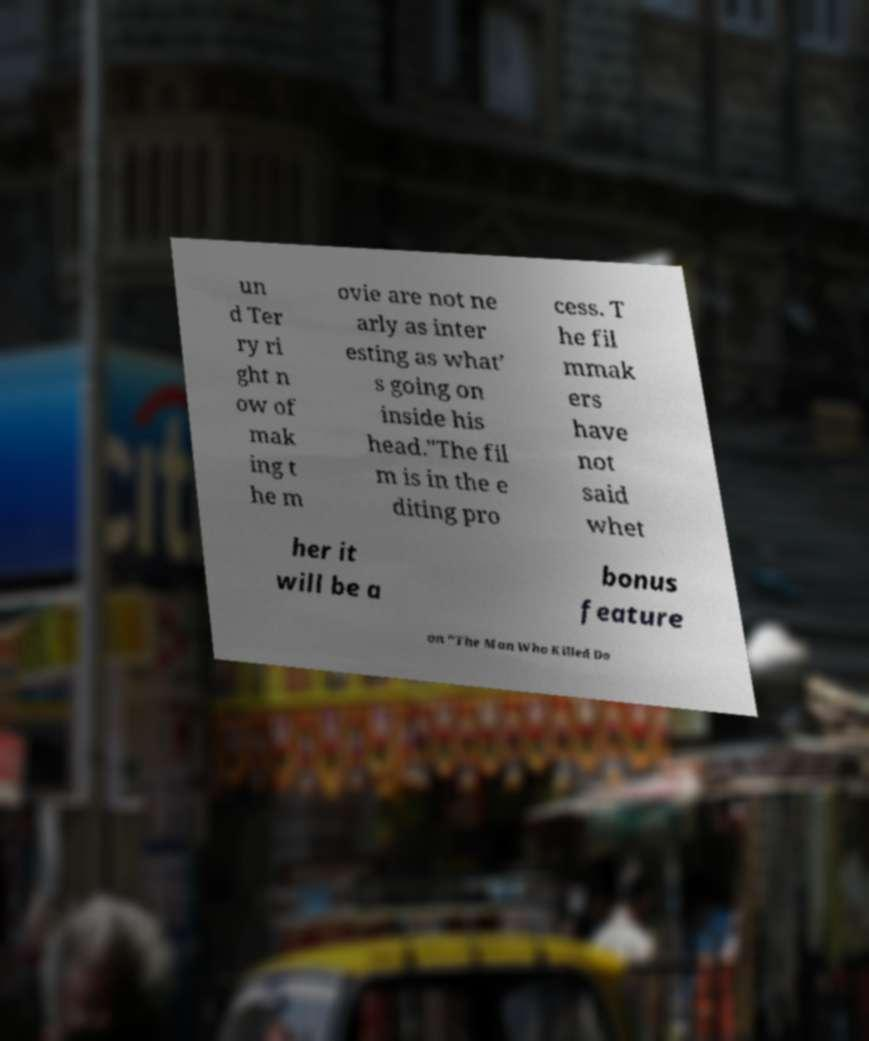For documentation purposes, I need the text within this image transcribed. Could you provide that? un d Ter ry ri ght n ow of mak ing t he m ovie are not ne arly as inter esting as what’ s going on inside his head."The fil m is in the e diting pro cess. T he fil mmak ers have not said whet her it will be a bonus feature on "The Man Who Killed Do 